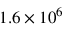Convert formula to latex. <formula><loc_0><loc_0><loc_500><loc_500>1 . 6 \times 1 0 ^ { 6 }</formula> 